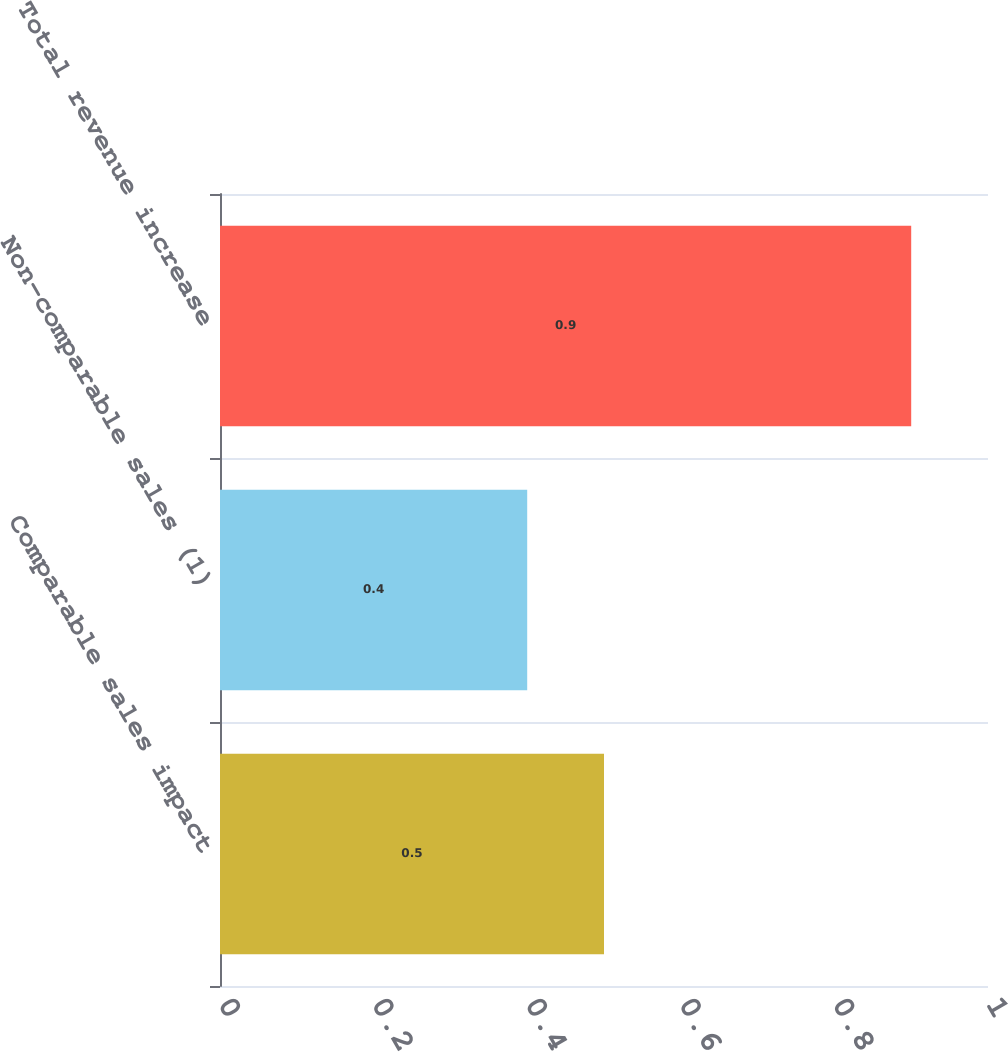Convert chart to OTSL. <chart><loc_0><loc_0><loc_500><loc_500><bar_chart><fcel>Comparable sales impact<fcel>Non-comparable sales (1)<fcel>Total revenue increase<nl><fcel>0.5<fcel>0.4<fcel>0.9<nl></chart> 